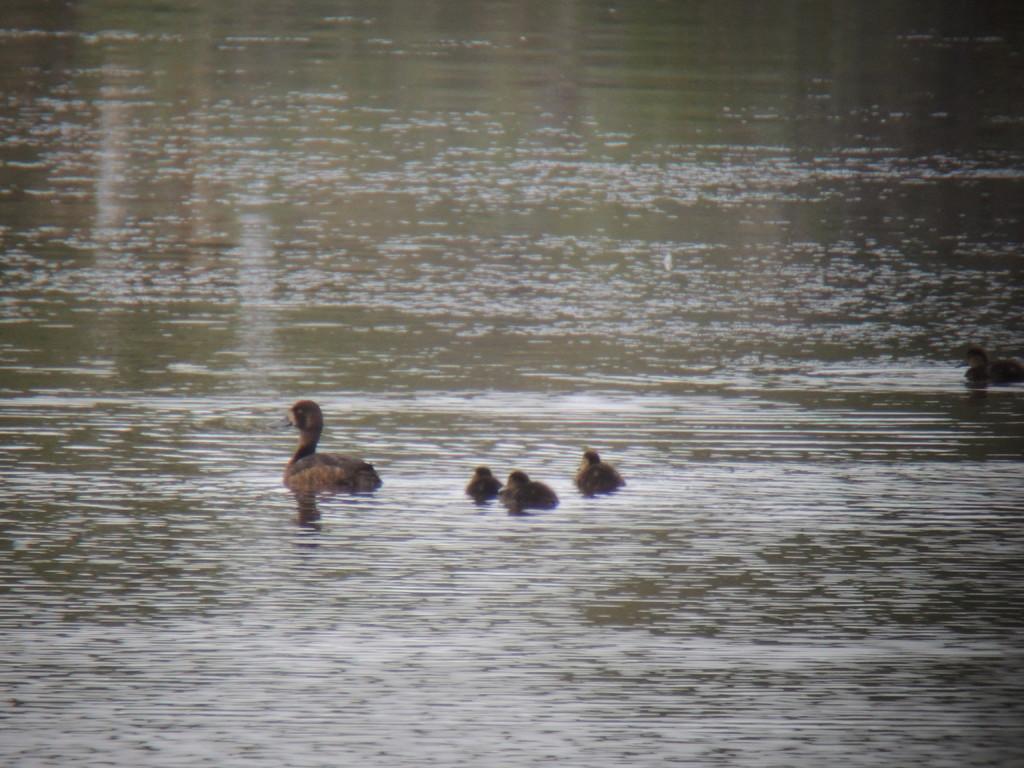Could you give a brief overview of what you see in this image? This picture is clicked outside the city. In the center we can see a bird and some other objects in the water body. 